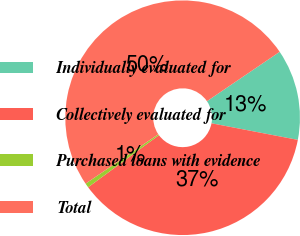Convert chart to OTSL. <chart><loc_0><loc_0><loc_500><loc_500><pie_chart><fcel>Individually evaluated for<fcel>Collectively evaluated for<fcel>Purchased loans with evidence<fcel>Total<nl><fcel>12.52%<fcel>36.88%<fcel>0.6%<fcel>50.0%<nl></chart> 